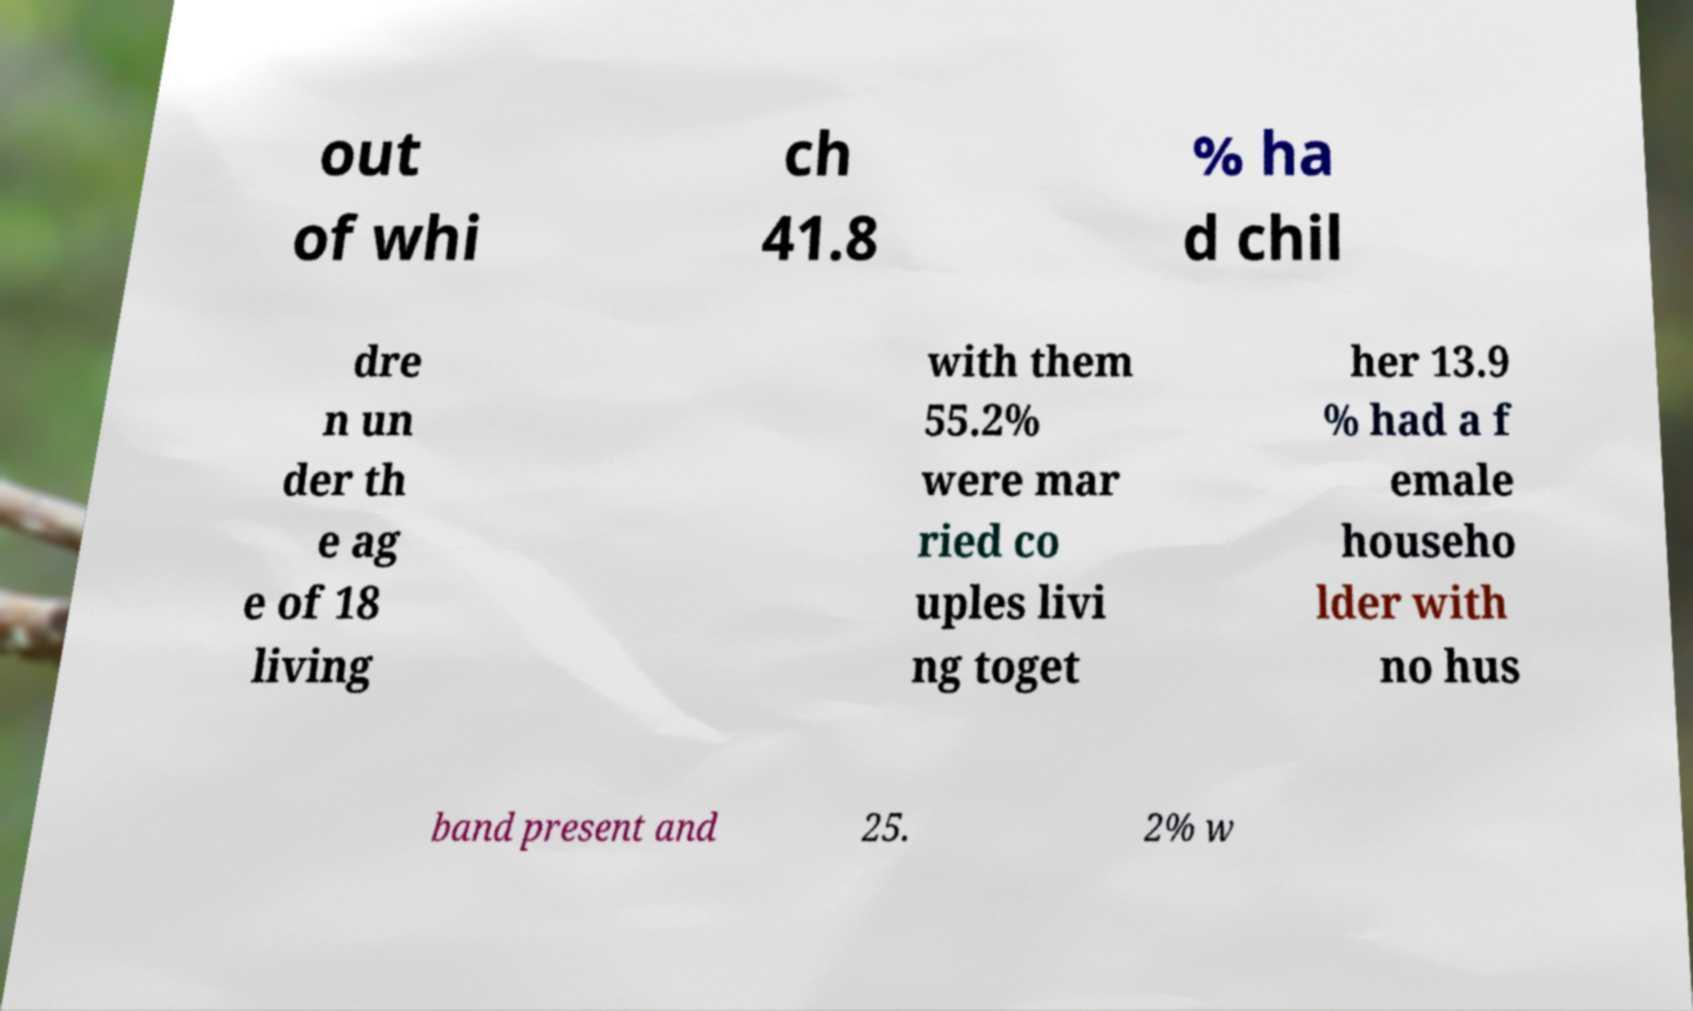Could you assist in decoding the text presented in this image and type it out clearly? out of whi ch 41.8 % ha d chil dre n un der th e ag e of 18 living with them 55.2% were mar ried co uples livi ng toget her 13.9 % had a f emale househo lder with no hus band present and 25. 2% w 